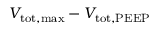Convert formula to latex. <formula><loc_0><loc_0><loc_500><loc_500>V _ { t o t , \max } - V _ { t o t , P E E P }</formula> 